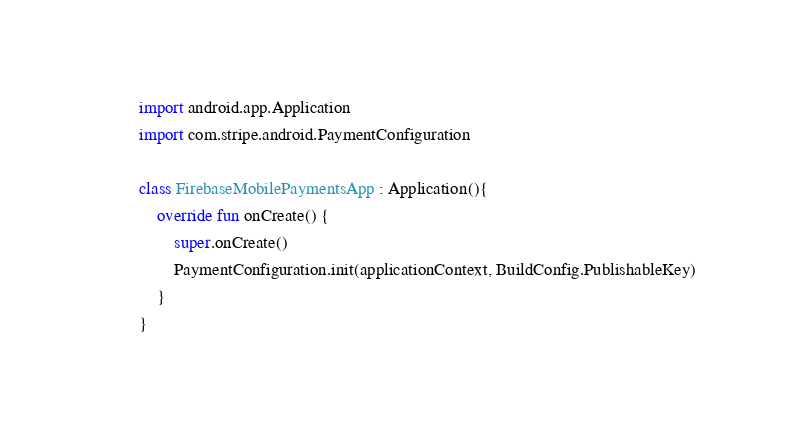Convert code to text. <code><loc_0><loc_0><loc_500><loc_500><_Kotlin_>
import android.app.Application
import com.stripe.android.PaymentConfiguration

class FirebaseMobilePaymentsApp : Application(){
    override fun onCreate() {
        super.onCreate()
        PaymentConfiguration.init(applicationContext, BuildConfig.PublishableKey)
    }
}</code> 